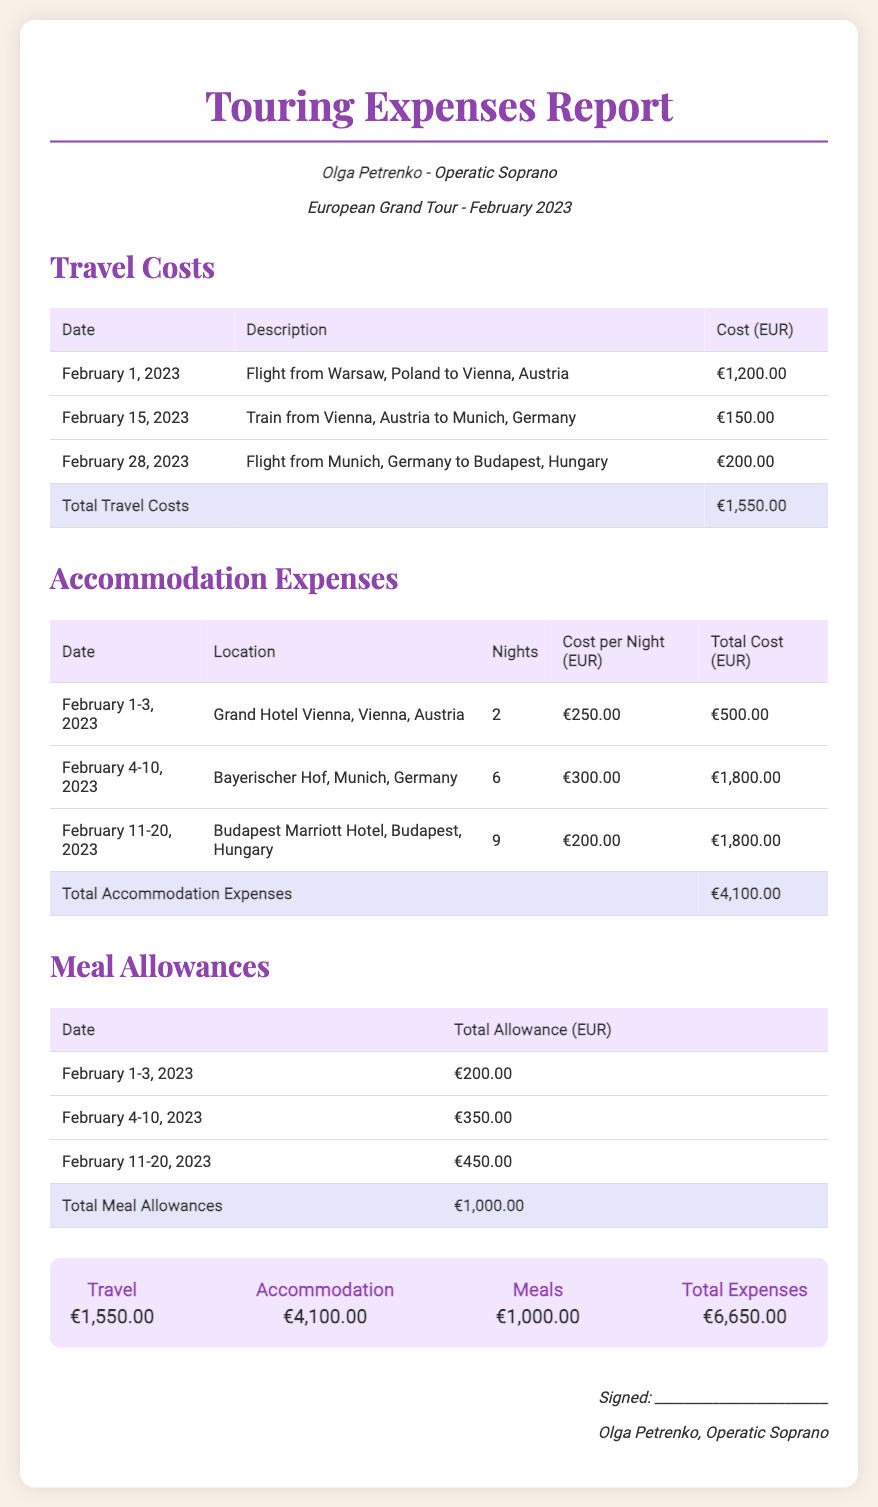what is the total travel cost? The total travel cost is explicitly stated in the table as €1,550.00.
Answer: €1,550.00 how many nights did Olga stay in Munich? The document shows that Olga stayed in Munich for 6 nights according to the accommodation expenses table.
Answer: 6 what is the location of the Grand Hotel? The Grand Hotel is located in Vienna, Austria as per the accommodation table.
Answer: Vienna, Austria what was the total meal allowance for February 4-10, 2023? The total allowance for that specific period is provided in the meal allowances table as €350.00.
Answer: €350.00 how much did Olga spend on accommodation? The total accommodation expenses are summarized in the document as €4,100.00.
Answer: €4,100.00 what is the duration of Olga's stay in Budapest? The document indicates that Olga stayed in Budapest for 9 nights.
Answer: 9 what were the travel costs for February 28, 2023? The travel cost for that date, specifically for the flight from Munich to Budapest, is €200.00 as shown in the travel costs table.
Answer: €200.00 what is the total amount of all expenses? The total expenses are calculated and presented in the summary section as €6,650.00.
Answer: €6,650.00 